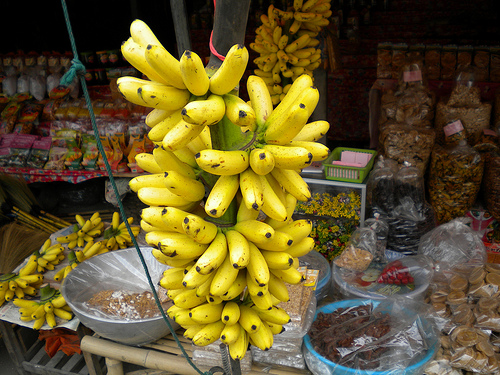Please provide a short description for this region: [0.12, 0.6, 0.41, 0.83]. This area seems to contain a bowl with various spices or condiments, adding a burst of different hues and a promise of flavor to whoever passes by. 